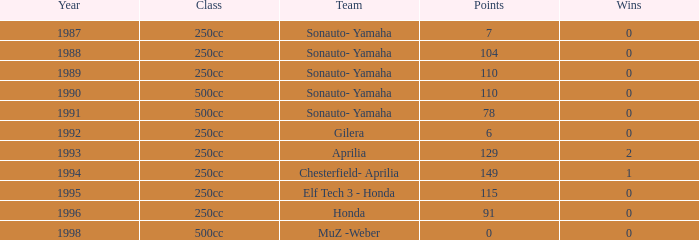How many wins did the team, which had more than 110 points, have in 1989? None. 